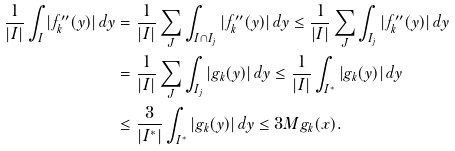Convert formula to latex. <formula><loc_0><loc_0><loc_500><loc_500>\frac { 1 } { | I | } \int _ { I } | f _ { k } ^ { \prime \prime } ( y ) | \, d y & = \frac { 1 } { | I | } \sum _ { J } \int _ { I \cap I _ { j } } | f _ { k } ^ { \prime \prime } ( y ) | \, d y \leq \frac { 1 } { | I | } \sum _ { J } \int _ { I _ { j } } | f _ { k } ^ { \prime \prime } ( y ) | \, d y \\ & = \frac { 1 } { | I | } \sum _ { J } \int _ { I _ { j } } | g _ { k } ( y ) | \, d y \leq \frac { 1 } { | I | } \int _ { I ^ { * } } | g _ { k } ( y ) | \, d y \\ & \leq \frac { 3 } { | I ^ { * } | } \int _ { I ^ { * } } | g _ { k } ( y ) | \, d y \leq 3 M g _ { k } ( x ) .</formula> 